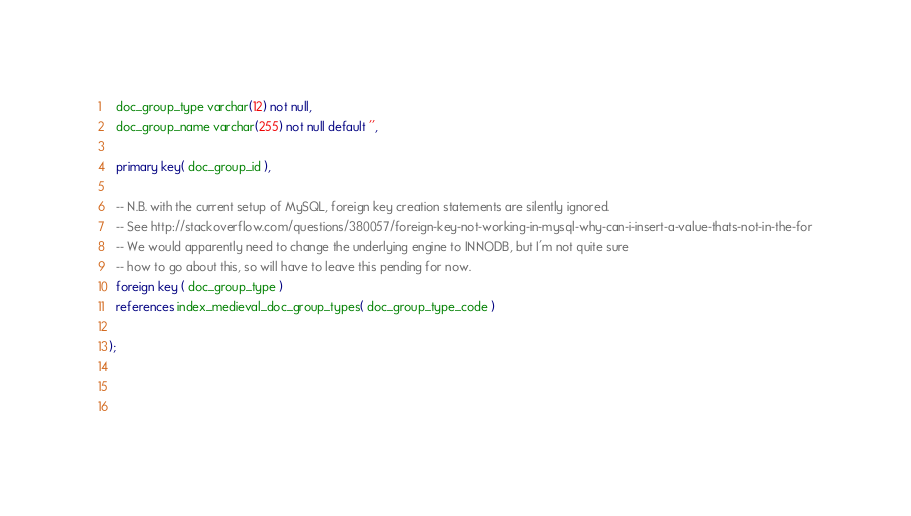<code> <loc_0><loc_0><loc_500><loc_500><_SQL_>  doc_group_type varchar(12) not null, 
  doc_group_name varchar(255) not null default '',

  primary key( doc_group_id ),

  -- N.B. with the current setup of MySQL, foreign key creation statements are silently ignored.
  -- See http://stackoverflow.com/questions/380057/foreign-key-not-working-in-mysql-why-can-i-insert-a-value-thats-not-in-the-for
  -- We would apparently need to change the underlying engine to INNODB, but I'm not quite sure
  -- how to go about this, so will have to leave this pending for now.
  foreign key ( doc_group_type )
  references index_medieval_doc_group_types( doc_group_type_code )
  
);


 
</code> 